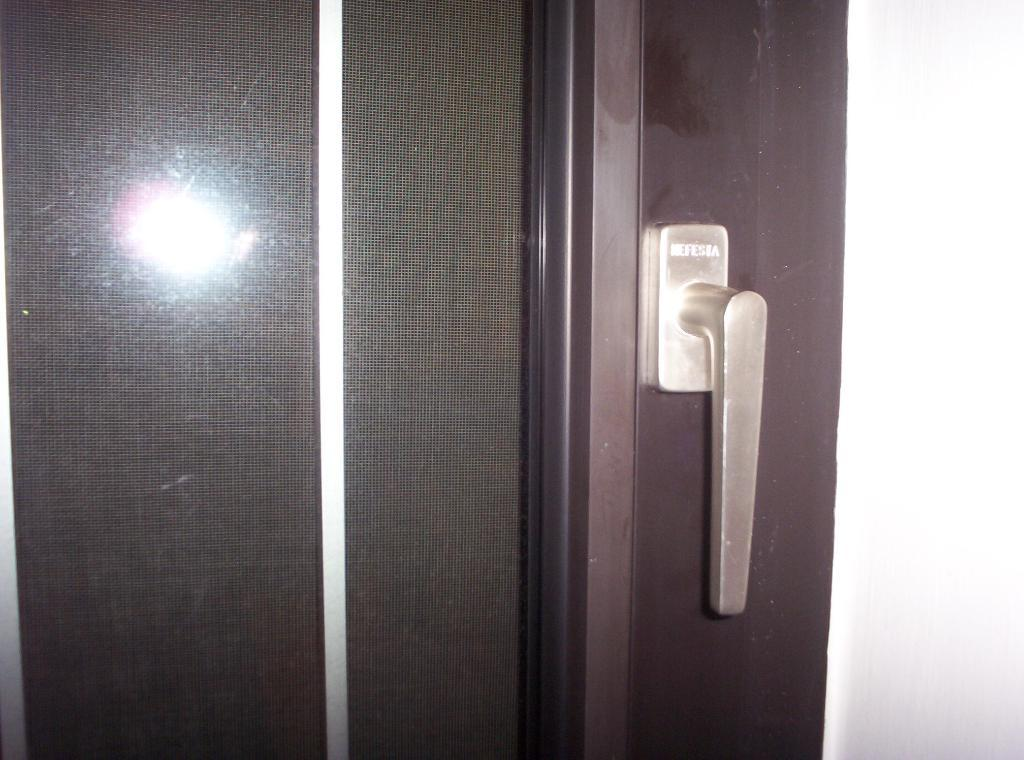What object is in the image that people use to open doors? There is a door handle in the image. What material is the door handle attached to? The door handle is attached to a wooden door. Can you describe any visual effects in the image? There appears to be a reflection of light in the image. What type of mint is growing near the door handle in the image? There is no mint present in the image; it only features a door handle and a wooden door. 